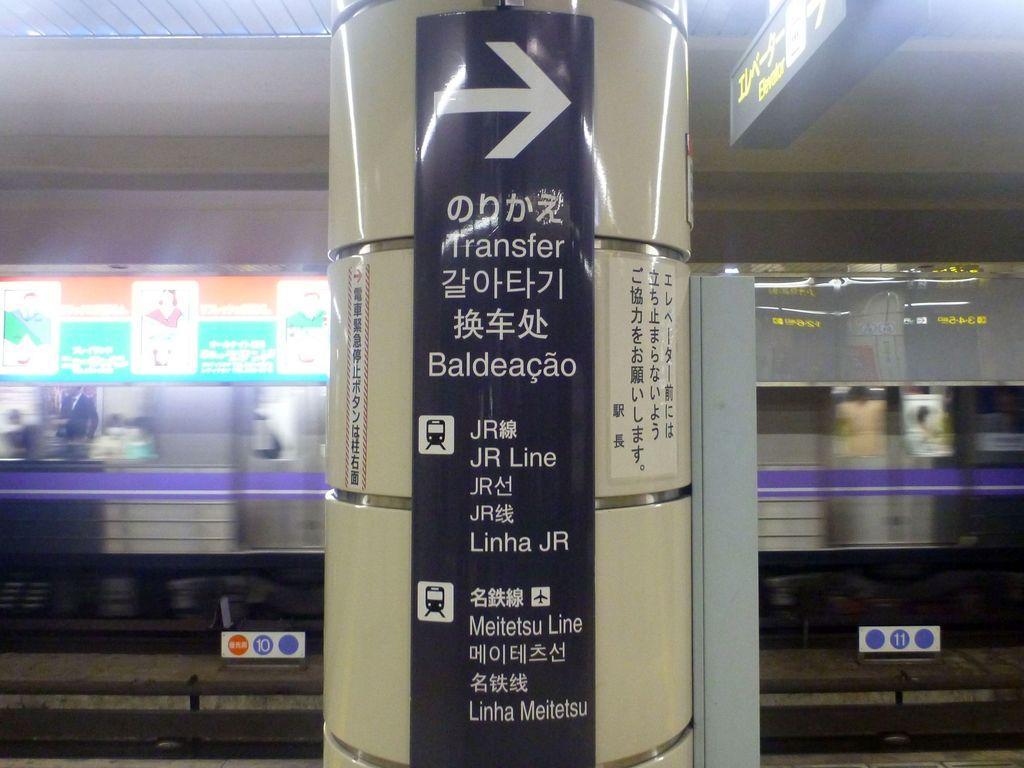<image>
Describe the image concisely. A column in a subway station directing the users toward a Transfer. 